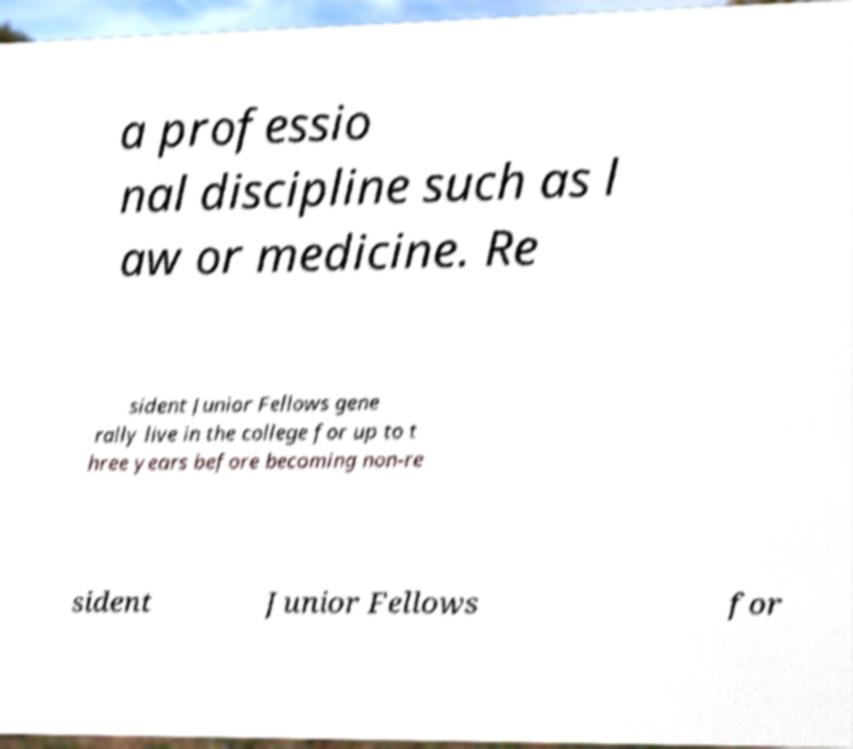Can you accurately transcribe the text from the provided image for me? a professio nal discipline such as l aw or medicine. Re sident Junior Fellows gene rally live in the college for up to t hree years before becoming non-re sident Junior Fellows for 